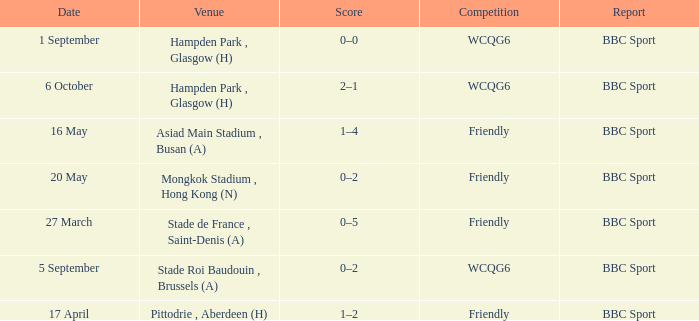Who reported the game played on 1 september? BBC Sport. 